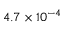Convert formula to latex. <formula><loc_0><loc_0><loc_500><loc_500>4 . 7 \times 1 0 ^ { - 4 }</formula> 